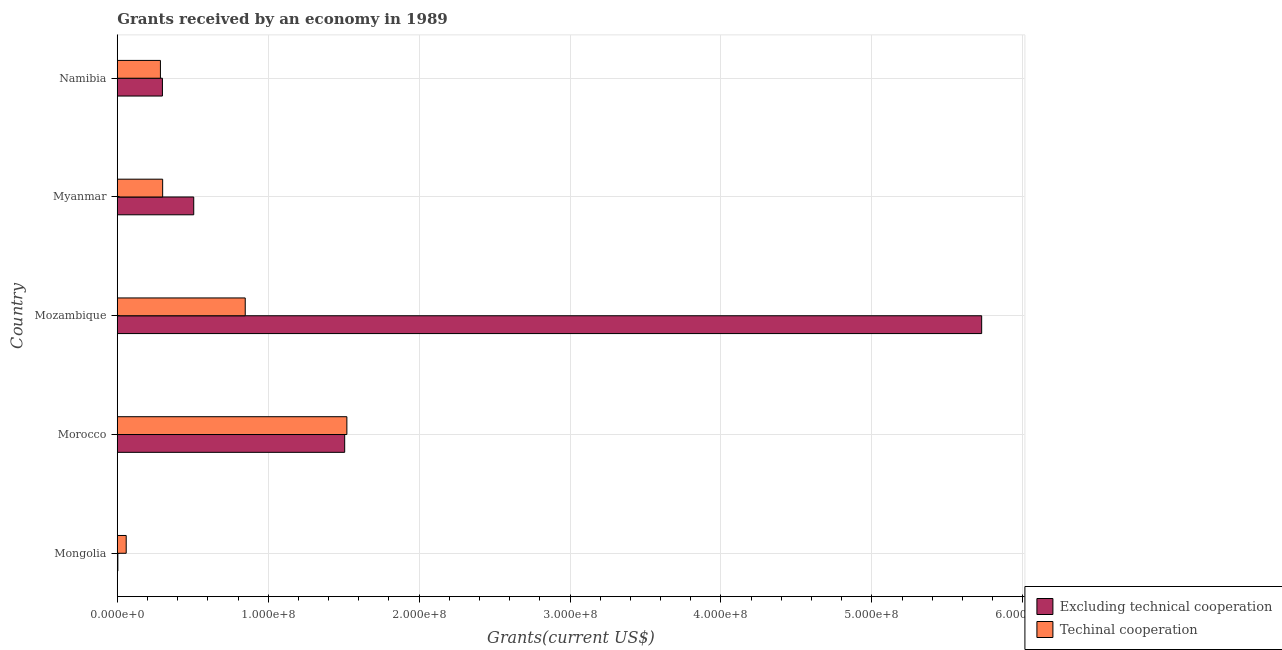How many different coloured bars are there?
Your answer should be compact. 2. How many groups of bars are there?
Give a very brief answer. 5. How many bars are there on the 1st tick from the top?
Offer a very short reply. 2. What is the label of the 3rd group of bars from the top?
Ensure brevity in your answer.  Mozambique. In how many cases, is the number of bars for a given country not equal to the number of legend labels?
Your response must be concise. 0. What is the amount of grants received(excluding technical cooperation) in Morocco?
Your response must be concise. 1.51e+08. Across all countries, what is the maximum amount of grants received(including technical cooperation)?
Ensure brevity in your answer.  1.52e+08. Across all countries, what is the minimum amount of grants received(including technical cooperation)?
Your answer should be compact. 5.91e+06. In which country was the amount of grants received(excluding technical cooperation) maximum?
Make the answer very short. Mozambique. In which country was the amount of grants received(including technical cooperation) minimum?
Offer a very short reply. Mongolia. What is the total amount of grants received(excluding technical cooperation) in the graph?
Your answer should be very brief. 8.04e+08. What is the difference between the amount of grants received(including technical cooperation) in Mozambique and that in Namibia?
Provide a succinct answer. 5.62e+07. What is the difference between the amount of grants received(including technical cooperation) in Mongolia and the amount of grants received(excluding technical cooperation) in Myanmar?
Your response must be concise. -4.48e+07. What is the average amount of grants received(including technical cooperation) per country?
Your response must be concise. 6.03e+07. What is the difference between the amount of grants received(excluding technical cooperation) and amount of grants received(including technical cooperation) in Morocco?
Give a very brief answer. -1.45e+06. What is the ratio of the amount of grants received(excluding technical cooperation) in Mozambique to that in Namibia?
Ensure brevity in your answer.  19.15. Is the difference between the amount of grants received(excluding technical cooperation) in Mozambique and Myanmar greater than the difference between the amount of grants received(including technical cooperation) in Mozambique and Myanmar?
Make the answer very short. Yes. What is the difference between the highest and the second highest amount of grants received(including technical cooperation)?
Provide a short and direct response. 6.74e+07. What is the difference between the highest and the lowest amount of grants received(excluding technical cooperation)?
Offer a very short reply. 5.72e+08. What does the 2nd bar from the top in Myanmar represents?
Provide a succinct answer. Excluding technical cooperation. What does the 1st bar from the bottom in Mozambique represents?
Your answer should be compact. Excluding technical cooperation. How many bars are there?
Keep it short and to the point. 10. Does the graph contain grids?
Keep it short and to the point. Yes. Where does the legend appear in the graph?
Make the answer very short. Bottom right. How many legend labels are there?
Your answer should be very brief. 2. What is the title of the graph?
Provide a succinct answer. Grants received by an economy in 1989. Does "IMF concessional" appear as one of the legend labels in the graph?
Give a very brief answer. No. What is the label or title of the X-axis?
Provide a short and direct response. Grants(current US$). What is the Grants(current US$) in Excluding technical cooperation in Mongolia?
Offer a very short reply. 3.80e+05. What is the Grants(current US$) of Techinal cooperation in Mongolia?
Your answer should be very brief. 5.91e+06. What is the Grants(current US$) in Excluding technical cooperation in Morocco?
Give a very brief answer. 1.51e+08. What is the Grants(current US$) in Techinal cooperation in Morocco?
Provide a succinct answer. 1.52e+08. What is the Grants(current US$) of Excluding technical cooperation in Mozambique?
Keep it short and to the point. 5.73e+08. What is the Grants(current US$) of Techinal cooperation in Mozambique?
Make the answer very short. 8.48e+07. What is the Grants(current US$) in Excluding technical cooperation in Myanmar?
Your answer should be very brief. 5.07e+07. What is the Grants(current US$) in Techinal cooperation in Myanmar?
Ensure brevity in your answer.  3.01e+07. What is the Grants(current US$) in Excluding technical cooperation in Namibia?
Your response must be concise. 2.99e+07. What is the Grants(current US$) of Techinal cooperation in Namibia?
Your answer should be very brief. 2.86e+07. Across all countries, what is the maximum Grants(current US$) of Excluding technical cooperation?
Your answer should be very brief. 5.73e+08. Across all countries, what is the maximum Grants(current US$) in Techinal cooperation?
Give a very brief answer. 1.52e+08. Across all countries, what is the minimum Grants(current US$) of Techinal cooperation?
Offer a terse response. 5.91e+06. What is the total Grants(current US$) of Excluding technical cooperation in the graph?
Provide a succinct answer. 8.04e+08. What is the total Grants(current US$) of Techinal cooperation in the graph?
Your response must be concise. 3.02e+08. What is the difference between the Grants(current US$) of Excluding technical cooperation in Mongolia and that in Morocco?
Your response must be concise. -1.50e+08. What is the difference between the Grants(current US$) of Techinal cooperation in Mongolia and that in Morocco?
Keep it short and to the point. -1.46e+08. What is the difference between the Grants(current US$) in Excluding technical cooperation in Mongolia and that in Mozambique?
Your response must be concise. -5.72e+08. What is the difference between the Grants(current US$) of Techinal cooperation in Mongolia and that in Mozambique?
Offer a terse response. -7.89e+07. What is the difference between the Grants(current US$) of Excluding technical cooperation in Mongolia and that in Myanmar?
Your response must be concise. -5.03e+07. What is the difference between the Grants(current US$) in Techinal cooperation in Mongolia and that in Myanmar?
Your answer should be compact. -2.42e+07. What is the difference between the Grants(current US$) of Excluding technical cooperation in Mongolia and that in Namibia?
Offer a terse response. -2.95e+07. What is the difference between the Grants(current US$) of Techinal cooperation in Mongolia and that in Namibia?
Give a very brief answer. -2.27e+07. What is the difference between the Grants(current US$) in Excluding technical cooperation in Morocco and that in Mozambique?
Provide a short and direct response. -4.22e+08. What is the difference between the Grants(current US$) of Techinal cooperation in Morocco and that in Mozambique?
Your answer should be compact. 6.74e+07. What is the difference between the Grants(current US$) of Excluding technical cooperation in Morocco and that in Myanmar?
Offer a very short reply. 1.00e+08. What is the difference between the Grants(current US$) of Techinal cooperation in Morocco and that in Myanmar?
Offer a terse response. 1.22e+08. What is the difference between the Grants(current US$) of Excluding technical cooperation in Morocco and that in Namibia?
Give a very brief answer. 1.21e+08. What is the difference between the Grants(current US$) in Techinal cooperation in Morocco and that in Namibia?
Your answer should be very brief. 1.24e+08. What is the difference between the Grants(current US$) of Excluding technical cooperation in Mozambique and that in Myanmar?
Make the answer very short. 5.22e+08. What is the difference between the Grants(current US$) of Techinal cooperation in Mozambique and that in Myanmar?
Your response must be concise. 5.47e+07. What is the difference between the Grants(current US$) of Excluding technical cooperation in Mozambique and that in Namibia?
Offer a terse response. 5.43e+08. What is the difference between the Grants(current US$) in Techinal cooperation in Mozambique and that in Namibia?
Make the answer very short. 5.62e+07. What is the difference between the Grants(current US$) of Excluding technical cooperation in Myanmar and that in Namibia?
Your answer should be compact. 2.08e+07. What is the difference between the Grants(current US$) in Techinal cooperation in Myanmar and that in Namibia?
Your answer should be compact. 1.48e+06. What is the difference between the Grants(current US$) in Excluding technical cooperation in Mongolia and the Grants(current US$) in Techinal cooperation in Morocco?
Offer a terse response. -1.52e+08. What is the difference between the Grants(current US$) in Excluding technical cooperation in Mongolia and the Grants(current US$) in Techinal cooperation in Mozambique?
Make the answer very short. -8.44e+07. What is the difference between the Grants(current US$) in Excluding technical cooperation in Mongolia and the Grants(current US$) in Techinal cooperation in Myanmar?
Ensure brevity in your answer.  -2.97e+07. What is the difference between the Grants(current US$) of Excluding technical cooperation in Mongolia and the Grants(current US$) of Techinal cooperation in Namibia?
Provide a short and direct response. -2.82e+07. What is the difference between the Grants(current US$) in Excluding technical cooperation in Morocco and the Grants(current US$) in Techinal cooperation in Mozambique?
Ensure brevity in your answer.  6.59e+07. What is the difference between the Grants(current US$) in Excluding technical cooperation in Morocco and the Grants(current US$) in Techinal cooperation in Myanmar?
Ensure brevity in your answer.  1.21e+08. What is the difference between the Grants(current US$) of Excluding technical cooperation in Morocco and the Grants(current US$) of Techinal cooperation in Namibia?
Keep it short and to the point. 1.22e+08. What is the difference between the Grants(current US$) in Excluding technical cooperation in Mozambique and the Grants(current US$) in Techinal cooperation in Myanmar?
Make the answer very short. 5.43e+08. What is the difference between the Grants(current US$) in Excluding technical cooperation in Mozambique and the Grants(current US$) in Techinal cooperation in Namibia?
Your answer should be compact. 5.44e+08. What is the difference between the Grants(current US$) in Excluding technical cooperation in Myanmar and the Grants(current US$) in Techinal cooperation in Namibia?
Provide a succinct answer. 2.21e+07. What is the average Grants(current US$) of Excluding technical cooperation per country?
Make the answer very short. 1.61e+08. What is the average Grants(current US$) of Techinal cooperation per country?
Give a very brief answer. 6.03e+07. What is the difference between the Grants(current US$) of Excluding technical cooperation and Grants(current US$) of Techinal cooperation in Mongolia?
Provide a short and direct response. -5.53e+06. What is the difference between the Grants(current US$) in Excluding technical cooperation and Grants(current US$) in Techinal cooperation in Morocco?
Offer a terse response. -1.45e+06. What is the difference between the Grants(current US$) of Excluding technical cooperation and Grants(current US$) of Techinal cooperation in Mozambique?
Offer a very short reply. 4.88e+08. What is the difference between the Grants(current US$) in Excluding technical cooperation and Grants(current US$) in Techinal cooperation in Myanmar?
Keep it short and to the point. 2.06e+07. What is the difference between the Grants(current US$) in Excluding technical cooperation and Grants(current US$) in Techinal cooperation in Namibia?
Your answer should be compact. 1.32e+06. What is the ratio of the Grants(current US$) of Excluding technical cooperation in Mongolia to that in Morocco?
Offer a very short reply. 0. What is the ratio of the Grants(current US$) in Techinal cooperation in Mongolia to that in Morocco?
Offer a very short reply. 0.04. What is the ratio of the Grants(current US$) in Excluding technical cooperation in Mongolia to that in Mozambique?
Ensure brevity in your answer.  0. What is the ratio of the Grants(current US$) in Techinal cooperation in Mongolia to that in Mozambique?
Make the answer very short. 0.07. What is the ratio of the Grants(current US$) of Excluding technical cooperation in Mongolia to that in Myanmar?
Your response must be concise. 0.01. What is the ratio of the Grants(current US$) in Techinal cooperation in Mongolia to that in Myanmar?
Make the answer very short. 0.2. What is the ratio of the Grants(current US$) in Excluding technical cooperation in Mongolia to that in Namibia?
Provide a short and direct response. 0.01. What is the ratio of the Grants(current US$) in Techinal cooperation in Mongolia to that in Namibia?
Offer a terse response. 0.21. What is the ratio of the Grants(current US$) in Excluding technical cooperation in Morocco to that in Mozambique?
Keep it short and to the point. 0.26. What is the ratio of the Grants(current US$) of Techinal cooperation in Morocco to that in Mozambique?
Your answer should be compact. 1.79. What is the ratio of the Grants(current US$) in Excluding technical cooperation in Morocco to that in Myanmar?
Offer a terse response. 2.97. What is the ratio of the Grants(current US$) of Techinal cooperation in Morocco to that in Myanmar?
Offer a very short reply. 5.06. What is the ratio of the Grants(current US$) of Excluding technical cooperation in Morocco to that in Namibia?
Provide a short and direct response. 5.04. What is the ratio of the Grants(current US$) of Techinal cooperation in Morocco to that in Namibia?
Provide a short and direct response. 5.32. What is the ratio of the Grants(current US$) of Excluding technical cooperation in Mozambique to that in Myanmar?
Provide a succinct answer. 11.31. What is the ratio of the Grants(current US$) in Techinal cooperation in Mozambique to that in Myanmar?
Your response must be concise. 2.82. What is the ratio of the Grants(current US$) in Excluding technical cooperation in Mozambique to that in Namibia?
Offer a terse response. 19.15. What is the ratio of the Grants(current US$) in Techinal cooperation in Mozambique to that in Namibia?
Offer a very short reply. 2.97. What is the ratio of the Grants(current US$) of Excluding technical cooperation in Myanmar to that in Namibia?
Ensure brevity in your answer.  1.69. What is the ratio of the Grants(current US$) in Techinal cooperation in Myanmar to that in Namibia?
Make the answer very short. 1.05. What is the difference between the highest and the second highest Grants(current US$) of Excluding technical cooperation?
Your response must be concise. 4.22e+08. What is the difference between the highest and the second highest Grants(current US$) of Techinal cooperation?
Offer a very short reply. 6.74e+07. What is the difference between the highest and the lowest Grants(current US$) of Excluding technical cooperation?
Offer a terse response. 5.72e+08. What is the difference between the highest and the lowest Grants(current US$) of Techinal cooperation?
Keep it short and to the point. 1.46e+08. 